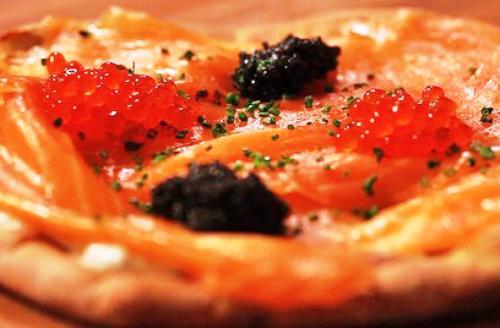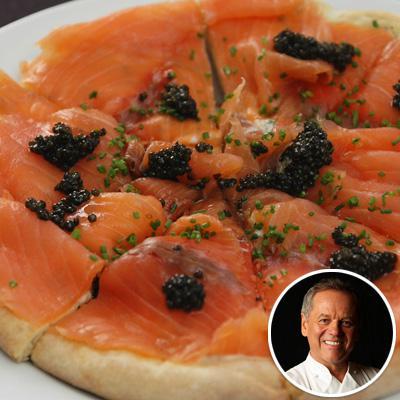The first image is the image on the left, the second image is the image on the right. Examine the images to the left and right. Is the description "In at least one image there is a salmon and carvery pizza with at least six slices." accurate? Answer yes or no. Yes. 